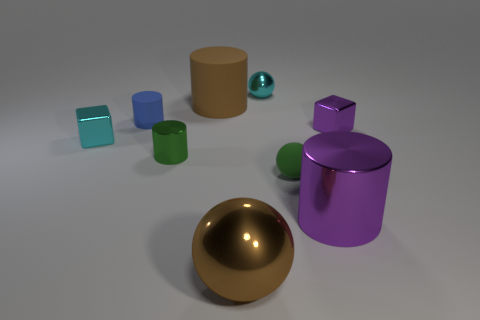How many other things are there of the same color as the rubber sphere?
Provide a succinct answer. 1. There is a small cyan metallic object on the right side of the brown metallic ball; is its shape the same as the brown matte object?
Provide a short and direct response. No. There is another matte object that is the same shape as the big brown matte thing; what color is it?
Make the answer very short. Blue. Are there any other things that have the same material as the purple block?
Your answer should be compact. Yes. What is the size of the cyan metallic thing that is the same shape as the small purple object?
Offer a very short reply. Small. What material is the cylinder that is to the left of the big brown rubber cylinder and right of the small matte cylinder?
Provide a short and direct response. Metal. Is the color of the metal sphere right of the brown ball the same as the tiny metal cylinder?
Make the answer very short. No. Does the big rubber cylinder have the same color as the metal object right of the large purple metallic thing?
Provide a succinct answer. No. There is a small cyan block; are there any metallic cubes to the right of it?
Your response must be concise. Yes. Is the blue cylinder made of the same material as the large brown cylinder?
Ensure brevity in your answer.  Yes. 